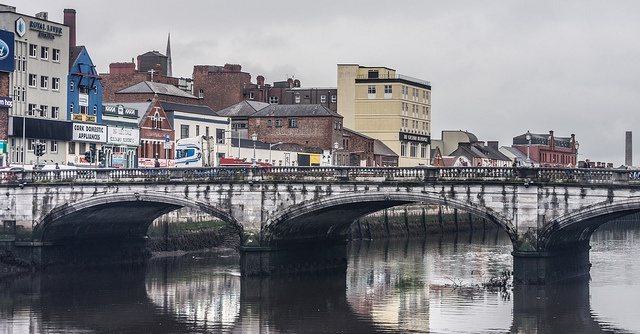Describe the objects in this image and their specific colors. I can see truck in lightgray, darkgray, blue, and gray tones, clock in lightgray, darkgray, gray, and black tones, people in lightgray, black, gray, and darkgray tones, car in lightgray, white, gray, and darkgray tones, and people in lightgray, black, and gray tones in this image. 